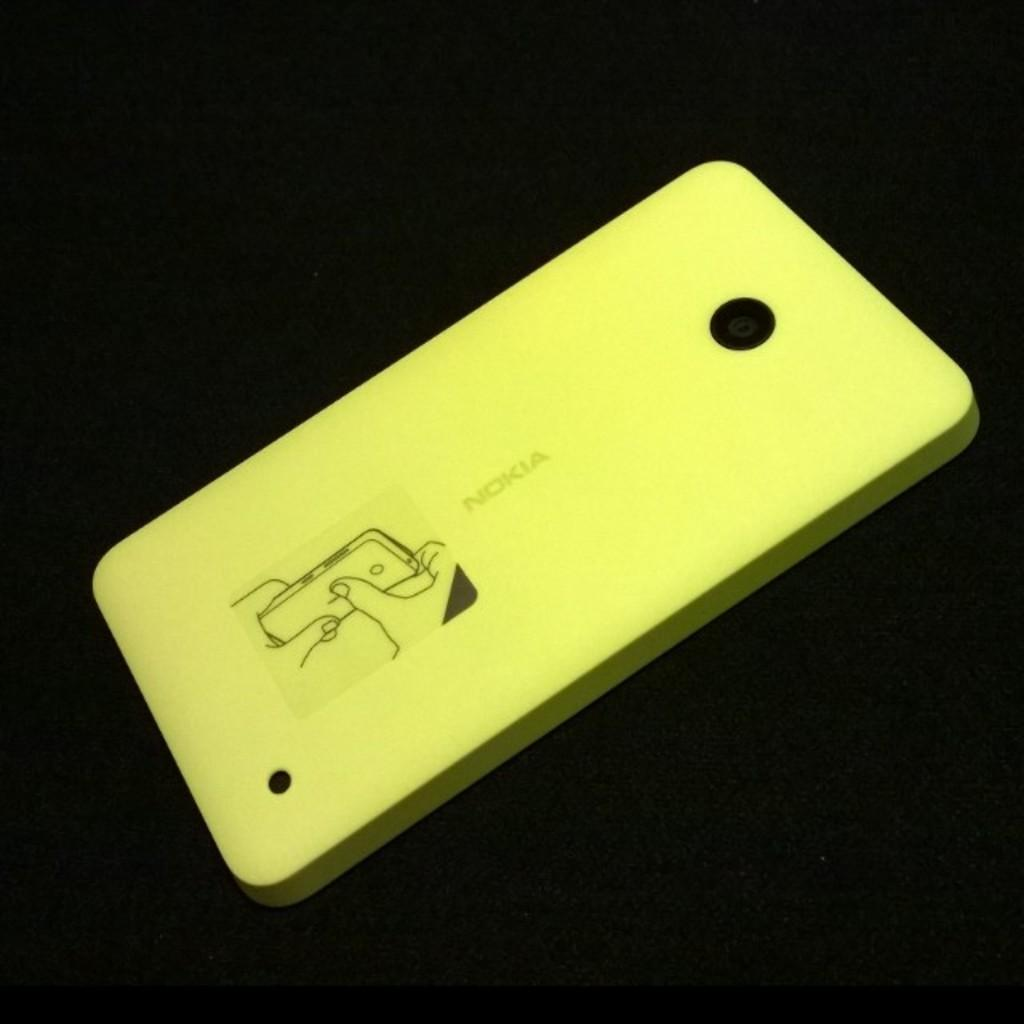Provide a one-sentence caption for the provided image. A yellow cover for a Nokia with instructions and pictures. 